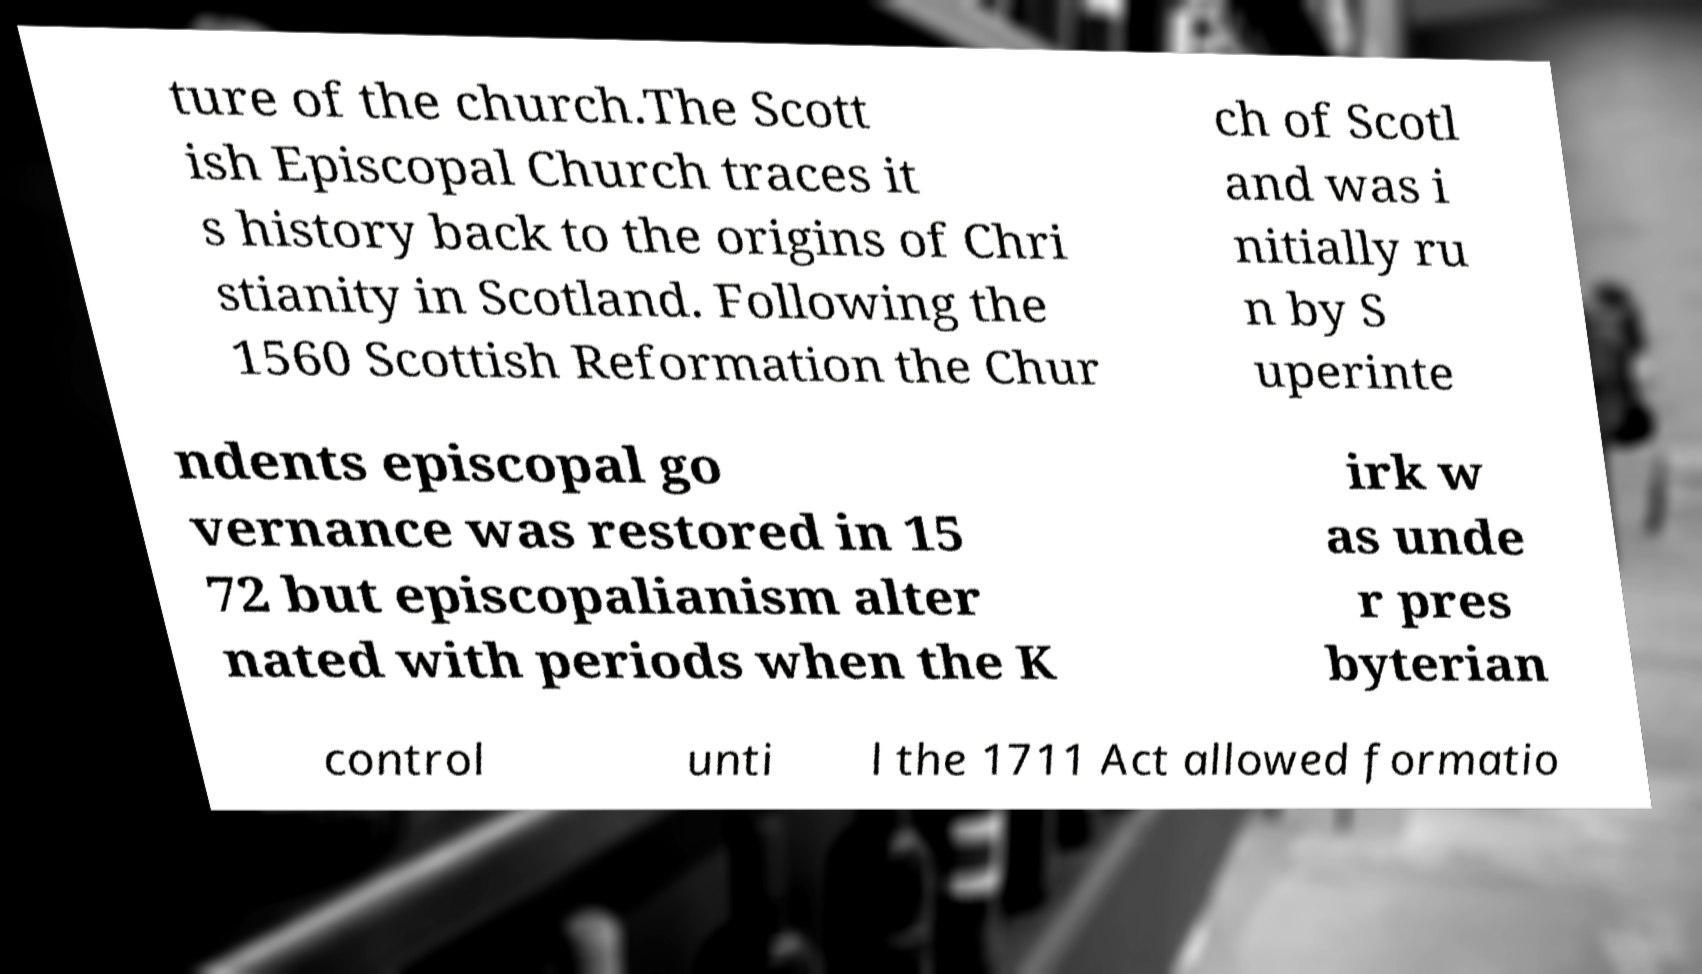Please read and relay the text visible in this image. What does it say? ture of the church.The Scott ish Episcopal Church traces it s history back to the origins of Chri stianity in Scotland. Following the 1560 Scottish Reformation the Chur ch of Scotl and was i nitially ru n by S uperinte ndents episcopal go vernance was restored in 15 72 but episcopalianism alter nated with periods when the K irk w as unde r pres byterian control unti l the 1711 Act allowed formatio 